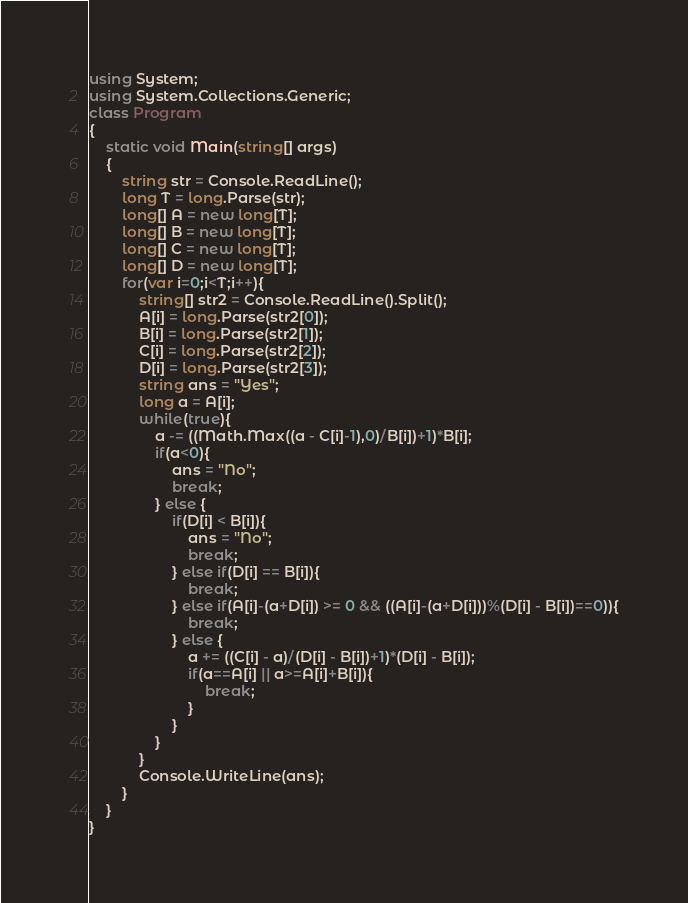Convert code to text. <code><loc_0><loc_0><loc_500><loc_500><_C#_>using System;
using System.Collections.Generic;
class Program
{
	static void Main(string[] args)
	{
		string str = Console.ReadLine();
		long T = long.Parse(str);
		long[] A = new long[T];
		long[] B = new long[T];
		long[] C = new long[T];
		long[] D = new long[T];
		for(var i=0;i<T;i++){
			string[] str2 = Console.ReadLine().Split();
			A[i] = long.Parse(str2[0]);
			B[i] = long.Parse(str2[1]);
			C[i] = long.Parse(str2[2]);
			D[i] = long.Parse(str2[3]);
			string ans = "Yes";
			long a = A[i];
			while(true){
				a -= ((Math.Max((a - C[i]-1),0)/B[i])+1)*B[i];
				if(a<0){
					ans = "No";
					break;
				} else {
					if(D[i] < B[i]){
						ans = "No";
						break;
					} else if(D[i] == B[i]){
						break;
					} else if(A[i]-(a+D[i]) >= 0 && ((A[i]-(a+D[i]))%(D[i] - B[i])==0)){
						break;
					} else {
						a += ((C[i] - a)/(D[i] - B[i])+1)*(D[i] - B[i]);
						if(a==A[i] || a>=A[i]+B[i]){
							break;
						}
					}
				}
			}
			Console.WriteLine(ans);
		}
	}
}</code> 